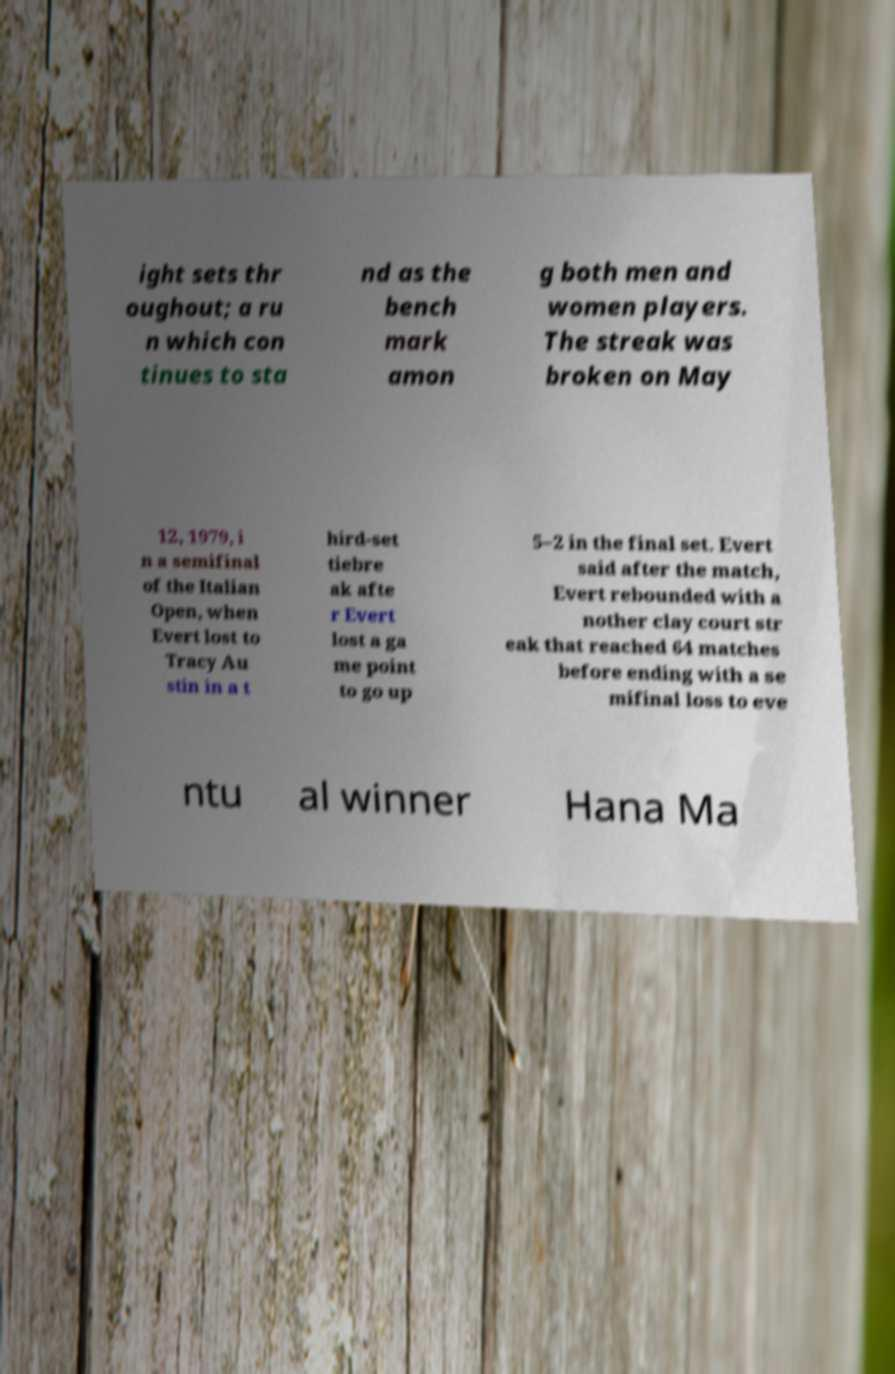Please identify and transcribe the text found in this image. ight sets thr oughout; a ru n which con tinues to sta nd as the bench mark amon g both men and women players. The streak was broken on May 12, 1979, i n a semifinal of the Italian Open, when Evert lost to Tracy Au stin in a t hird-set tiebre ak afte r Evert lost a ga me point to go up 5–2 in the final set. Evert said after the match, Evert rebounded with a nother clay court str eak that reached 64 matches before ending with a se mifinal loss to eve ntu al winner Hana Ma 